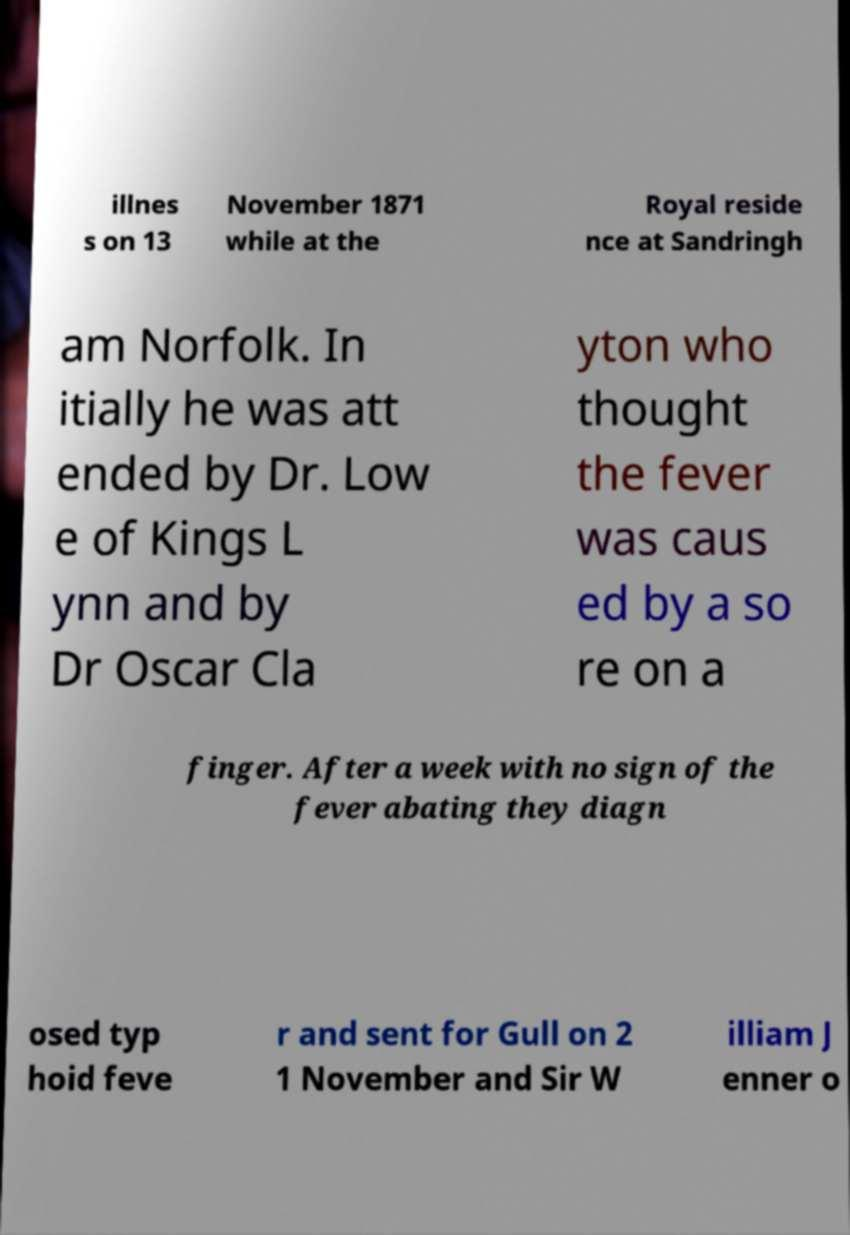Can you accurately transcribe the text from the provided image for me? illnes s on 13 November 1871 while at the Royal reside nce at Sandringh am Norfolk. In itially he was att ended by Dr. Low e of Kings L ynn and by Dr Oscar Cla yton who thought the fever was caus ed by a so re on a finger. After a week with no sign of the fever abating they diagn osed typ hoid feve r and sent for Gull on 2 1 November and Sir W illiam J enner o 